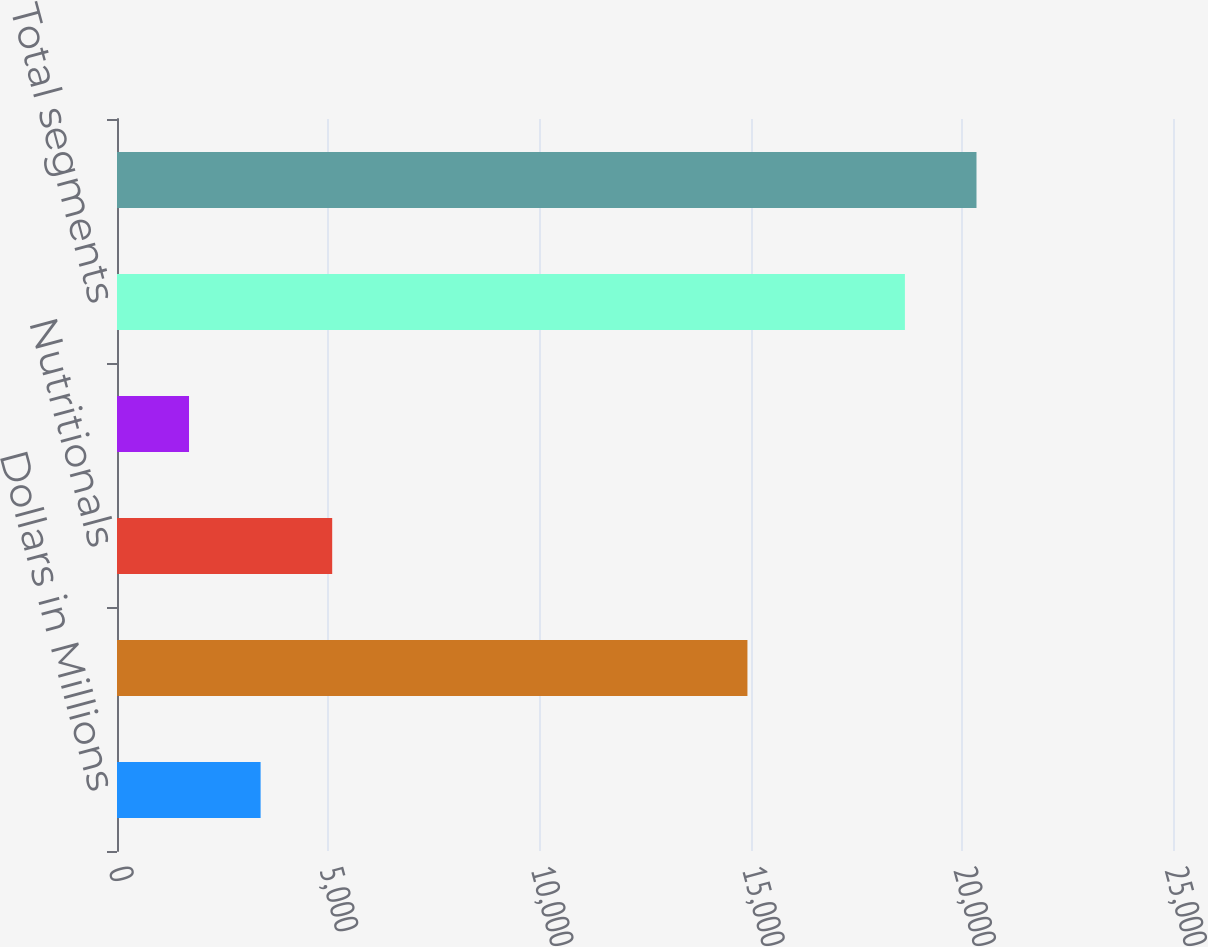Convert chart to OTSL. <chart><loc_0><loc_0><loc_500><loc_500><bar_chart><fcel>Dollars in Millions<fcel>Pharmaceuticals<fcel>Nutritionals<fcel>Other Healthcare<fcel>Total segments<fcel>Total<nl><fcel>3399.8<fcel>14925<fcel>5094.6<fcel>1705<fcel>18653<fcel>20347.8<nl></chart> 